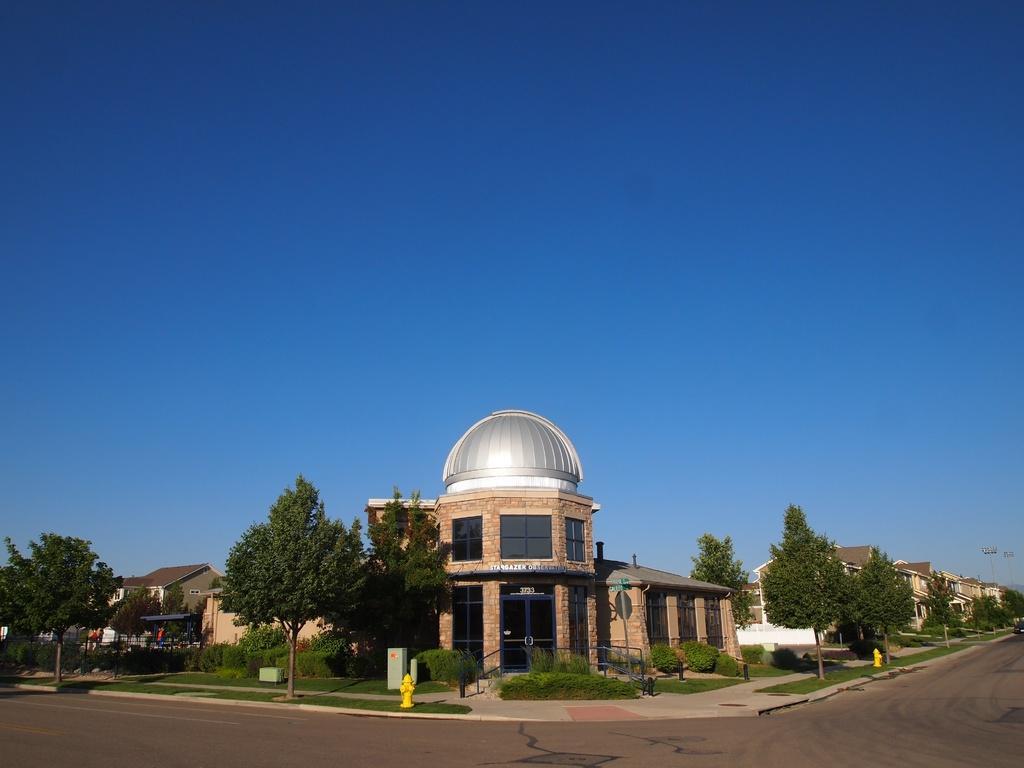Please provide a concise description of this image. At the bottom of this image, there is a manhole attached to the road. In the background, there are poles, trees and grass on the footpath, there are buildings, trees and plants on the ground and there are clouds in the blue sky. 